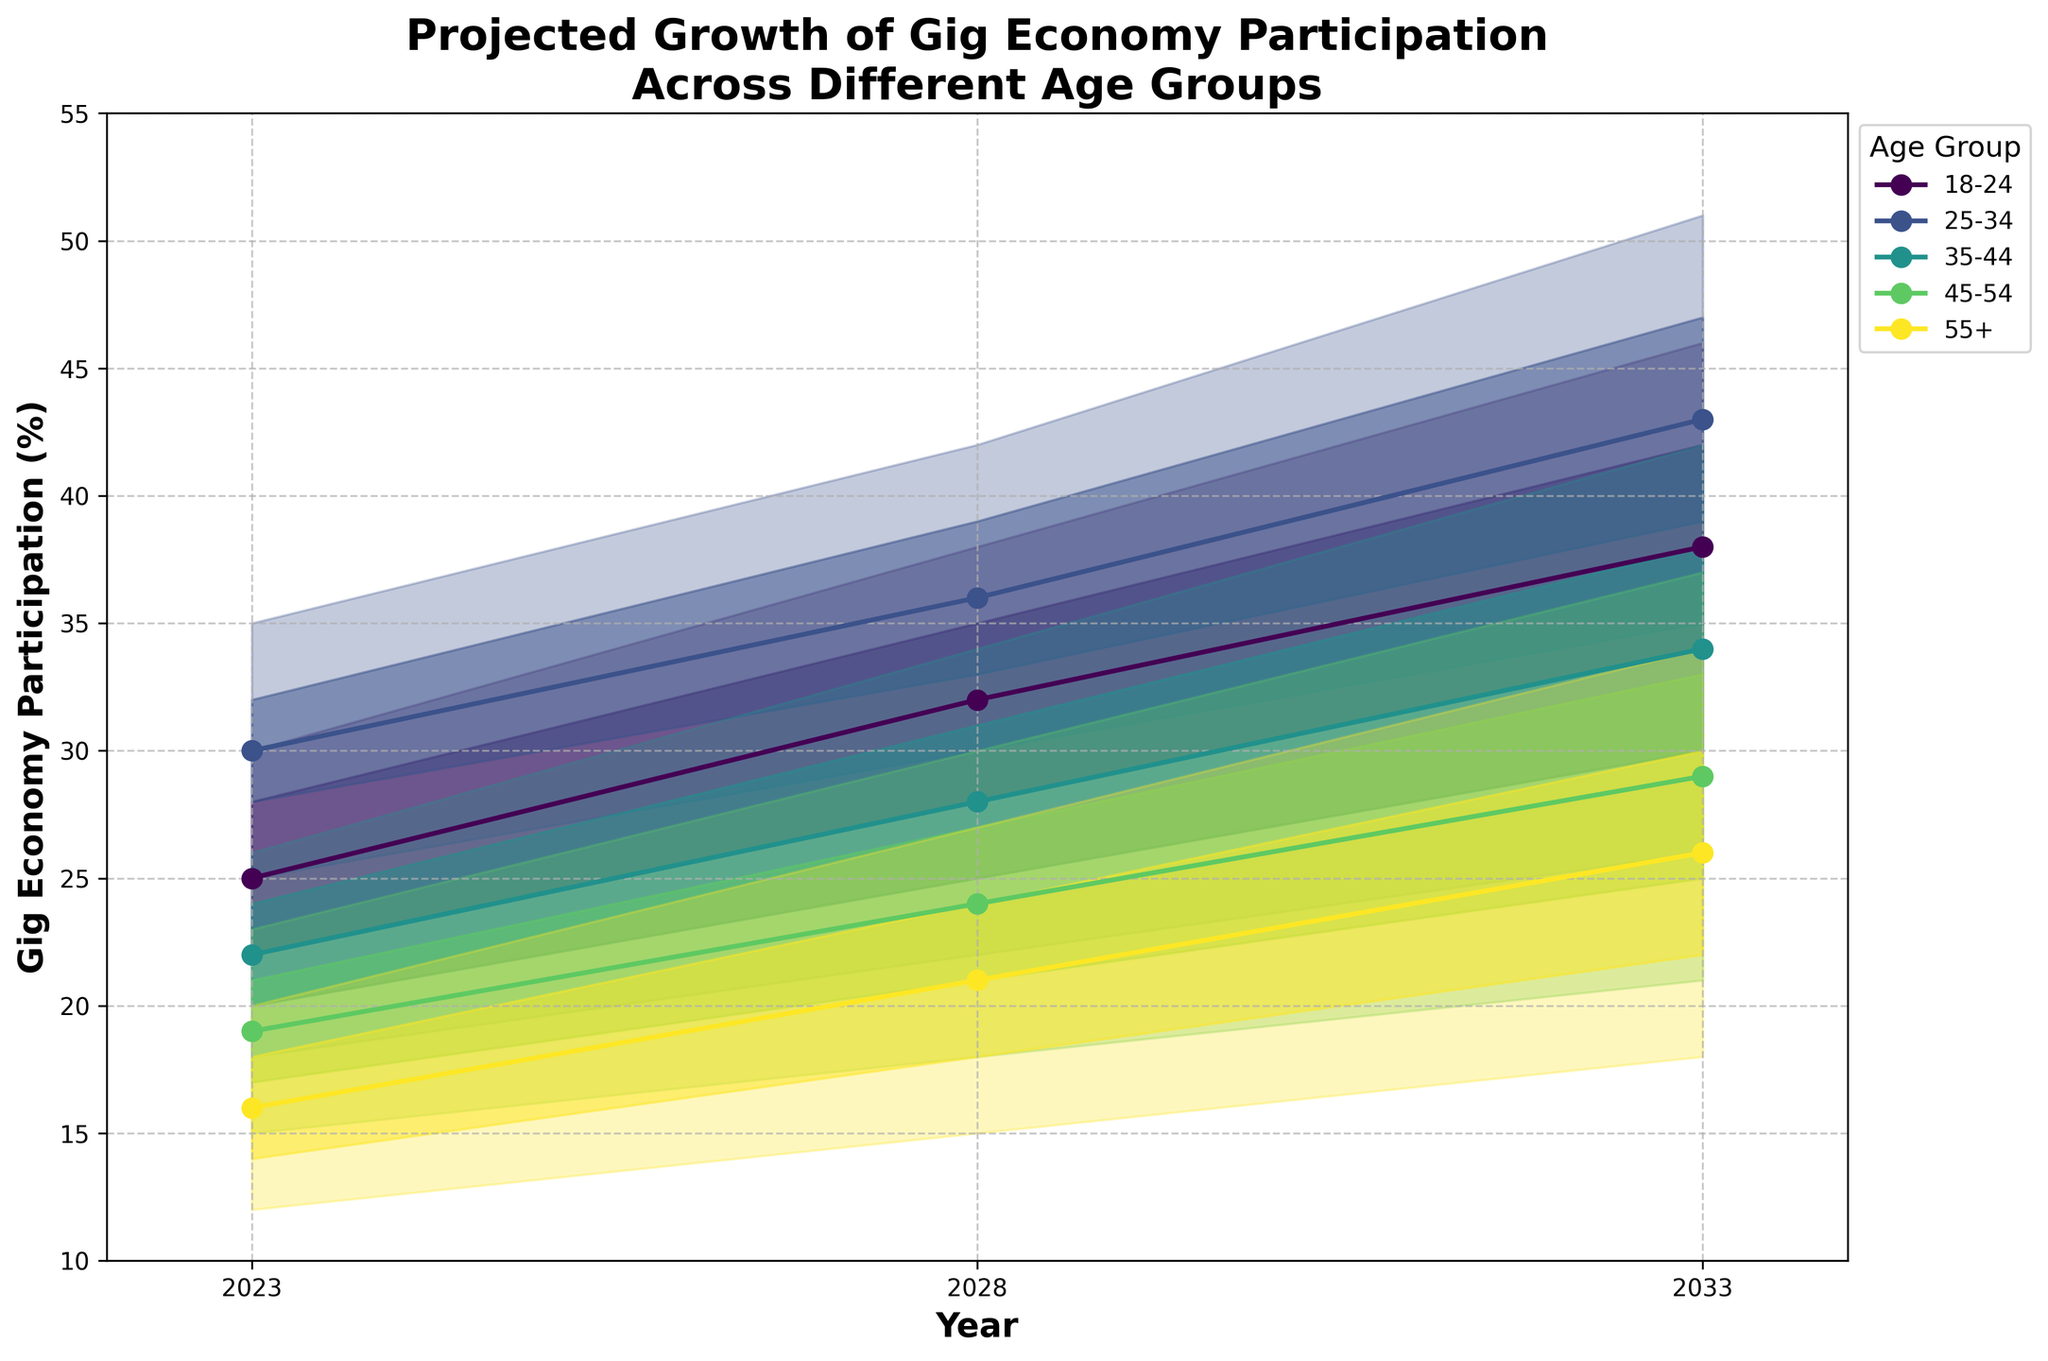What is the title of the figure? The title of the figure is displayed at the top of the chart, indicating the main subject of the plot.
Answer: Projected Growth of Gig Economy Participation Across Different Age Groups What is the participation percentage for the 25-34 age group in 2023 according to the mid estimate? Find the "25-34" age group on the chart and locate the value on the 'Mid Estimate' line for the year 2023.
Answer: 30% Which age group has the highest projected participation in the gig economy in 2033? Look for the age group with the highest position on the vertical axis in the year 2033.
Answer: 25-34 By how many percentage points is the mid estimate for the 45-54 age group expected to increase from 2023 to 2028? Subtract the mid estimate percentage of the 45-54 age group for 2023 from the mid estimate percentage for 2028.
Answer: 5 percentage points Which age group shows the smallest increase in their high estimate from 2023 to 2033? Calculate the difference between the high estimates of 2033 and 2023 and find the group with the smallest value.
Answer: 55+ What are the range of participation percentages for the 18-24 age group in 2028? Look at the 'High Estimate' and 'Low Estimate' for the 18-24 age group in 2028 to determine the range.
Answer: 25% to 38% Which age group has the lowest mid estimate of participation in 2023? Compare the mid estimate values of all age groups for the year 2023 and find the lowest one.
Answer: 55+ How does the estimated participation percentage of the 35-44 age group change from 2023 to 2028 according to the high-mid estimate? Subtract the high-mid estimate of 2023 from the high-mid estimate of 2028 for the 35-44 age group.
Answer: 7% In 2028, which age group shows the widest and narrowest range between their low and high estimates? Calculate the range (high estimate - low estimate) for each age group in 2028 and identify the widest and narrowest.
Answer: Widest: 25-34, Narrowest: 55+ What is the average high estimate percentage for all age groups in 2023? Sum the high estimate percentages for all age groups in 2023 and divide by the number of age groups.
Answer: (30+35+26+23+20)/5 = 26.8% 